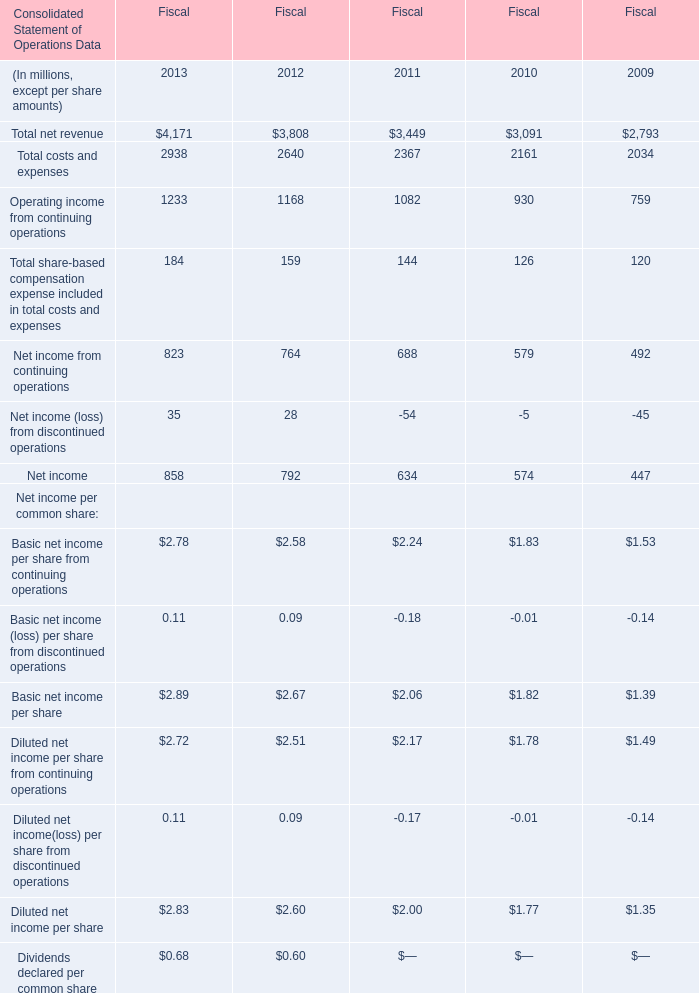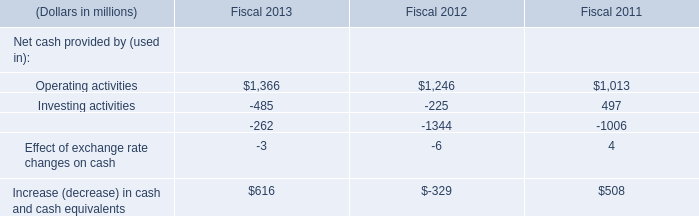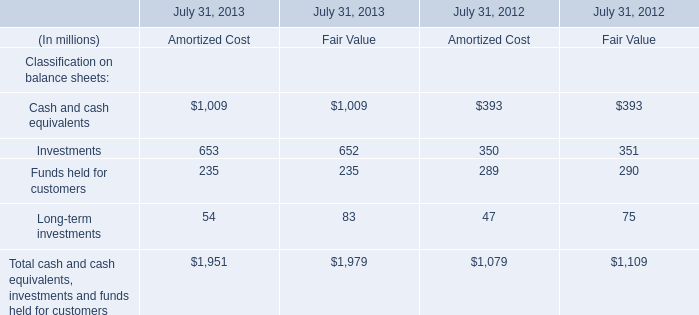What's the current increasing rate of Operating income from continuing operations in terms of Fiscal? 
Computations: ((1233 - 1168) / 1168)
Answer: 0.05565. 